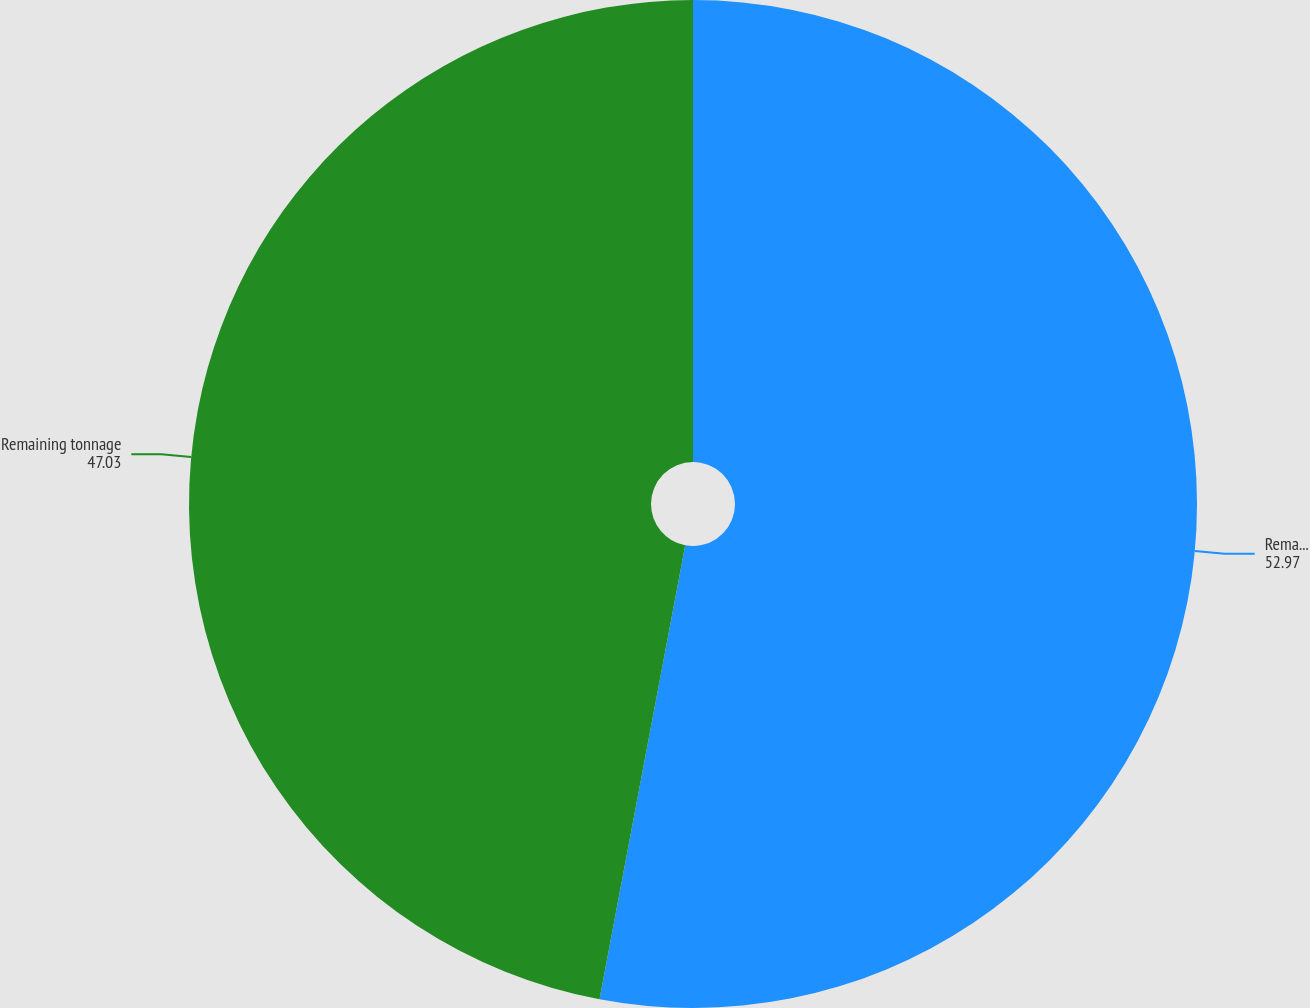<chart> <loc_0><loc_0><loc_500><loc_500><pie_chart><fcel>Remaining cubic yards<fcel>Remaining tonnage<nl><fcel>52.97%<fcel>47.03%<nl></chart> 